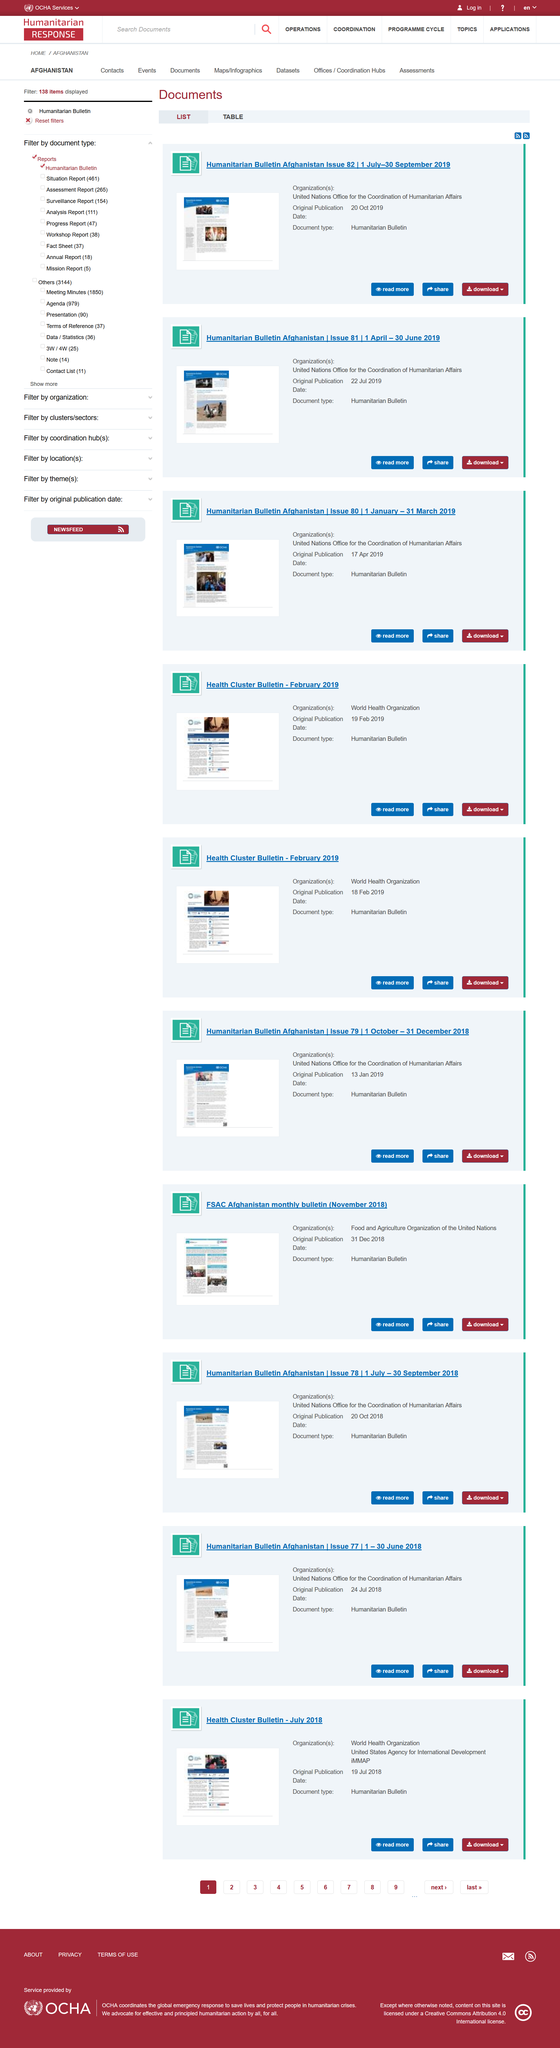Specify some key components in this picture. The document type of the Humanitarian Bulletin Afghanistan Issue 80 is a Humanitarian Bulletin. Humanitarian Bulletin Afghanistan Issue 82 was published on 20 October 2019. The Humanitarian Bulletin Afghanistan Issue 81 was originally published on 22 July 2019. 